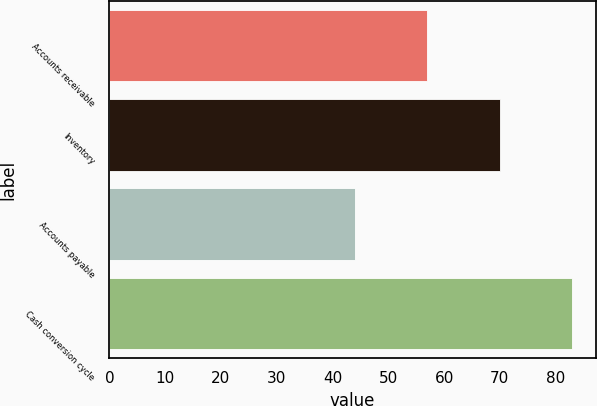<chart> <loc_0><loc_0><loc_500><loc_500><bar_chart><fcel>Accounts receivable<fcel>Inventory<fcel>Accounts payable<fcel>Cash conversion cycle<nl><fcel>57<fcel>70<fcel>44<fcel>83<nl></chart> 